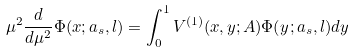<formula> <loc_0><loc_0><loc_500><loc_500>\mu ^ { 2 } \frac { d } { d \mu ^ { 2 } } \Phi ( x ; a _ { s } , l ) = \int ^ { 1 } _ { 0 } V ^ { ( 1 ) } ( x , y ; A ) \Phi ( y ; a _ { s } , l ) d y</formula> 